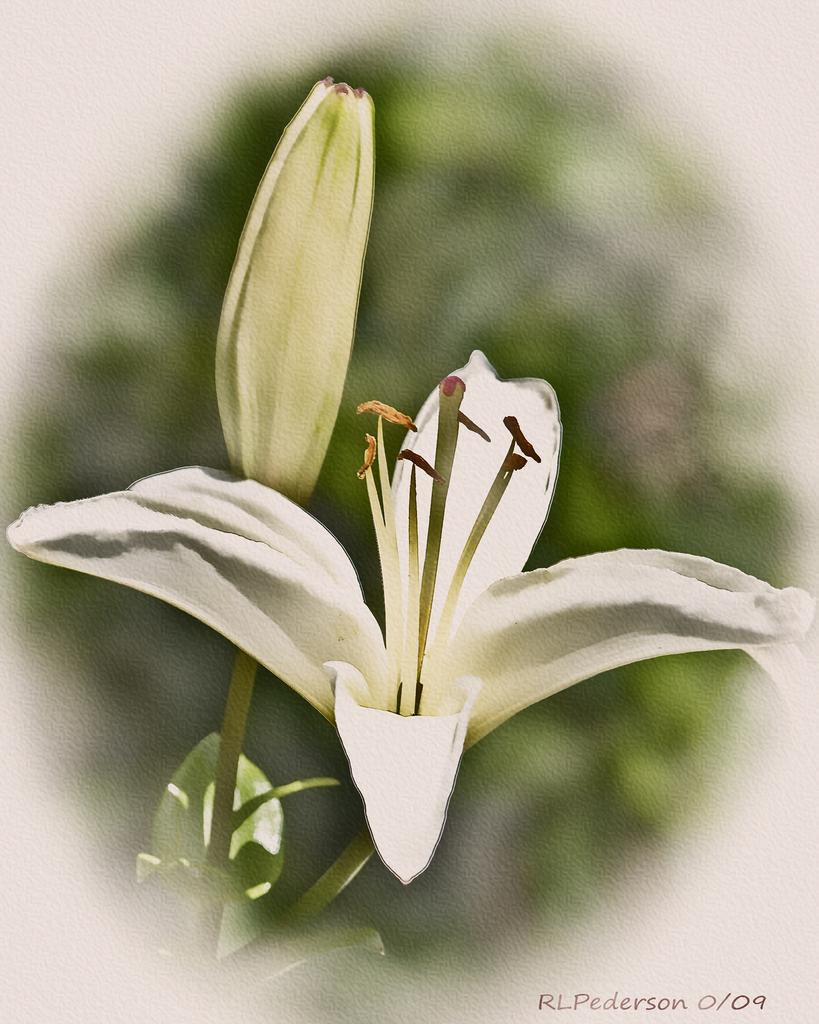What is the main subject of the image? There is a painting in the image. What does the painting depict? The painting depicts flowers and plants. What type of loaf is displayed on the shelf in the image? There is no loaf or shelf present in the image; it features a painting of flowers and plants. What kind of music can be heard playing in the background of the image? There is no music or indication of sound in the image, as it is a painting of flowers and plants. 